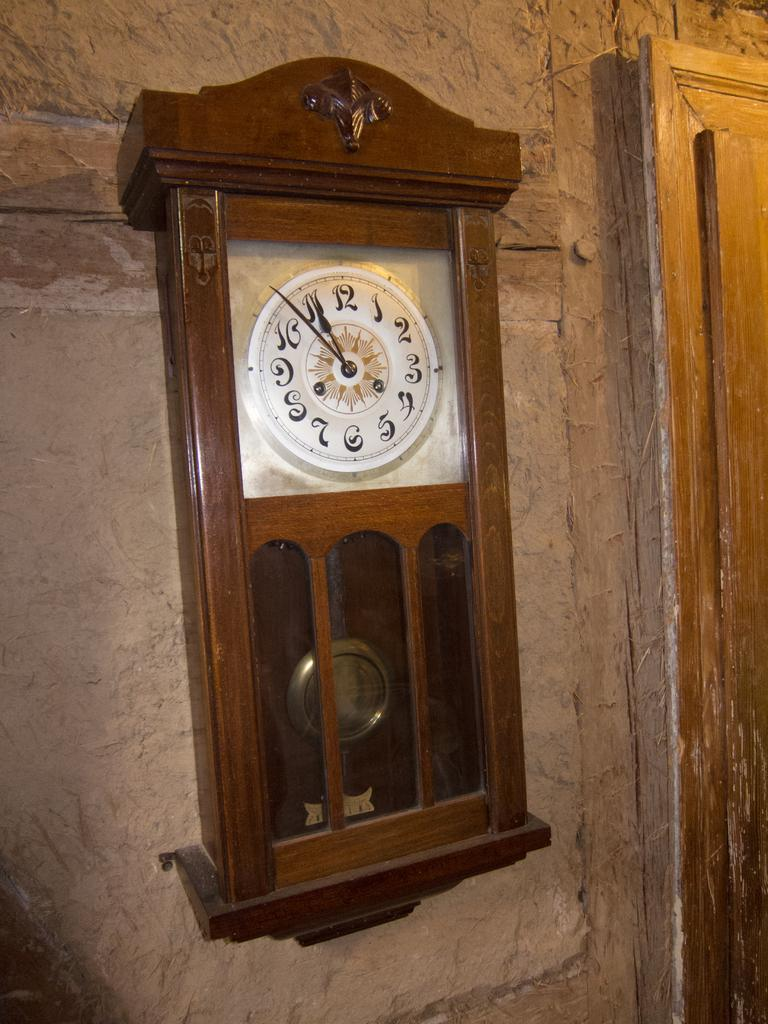What is the main object in the center of the image? There is a clock in the center of the image. What can be seen in the background of the image? There is a wall and a door in the background of the image. How many mice are sitting on the clock in the image? There are no mice present in the image. What type of meal is being prepared in the background of the image? There is no meal preparation visible in the image; it only features a clock, a wall, and a door. 